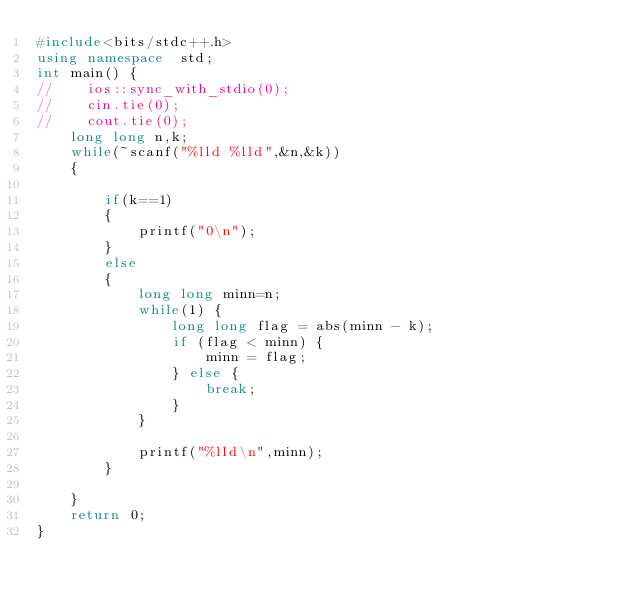<code> <loc_0><loc_0><loc_500><loc_500><_C++_>#include<bits/stdc++.h>
using namespace  std;
int main() {
//    ios::sync_with_stdio(0);
//    cin.tie(0);
//    cout.tie(0);
    long long n,k;
    while(~scanf("%lld %lld",&n,&k))
    {

        if(k==1)
        {
            printf("0\n");
        }
        else
        {
            long long minn=n;
            while(1) {
                long long flag = abs(minn - k);
                if (flag < minn) {
                    minn = flag;
                } else {
                    break;
                }
            }

            printf("%lld\n",minn);
        }

    }
    return 0;
}
</code> 